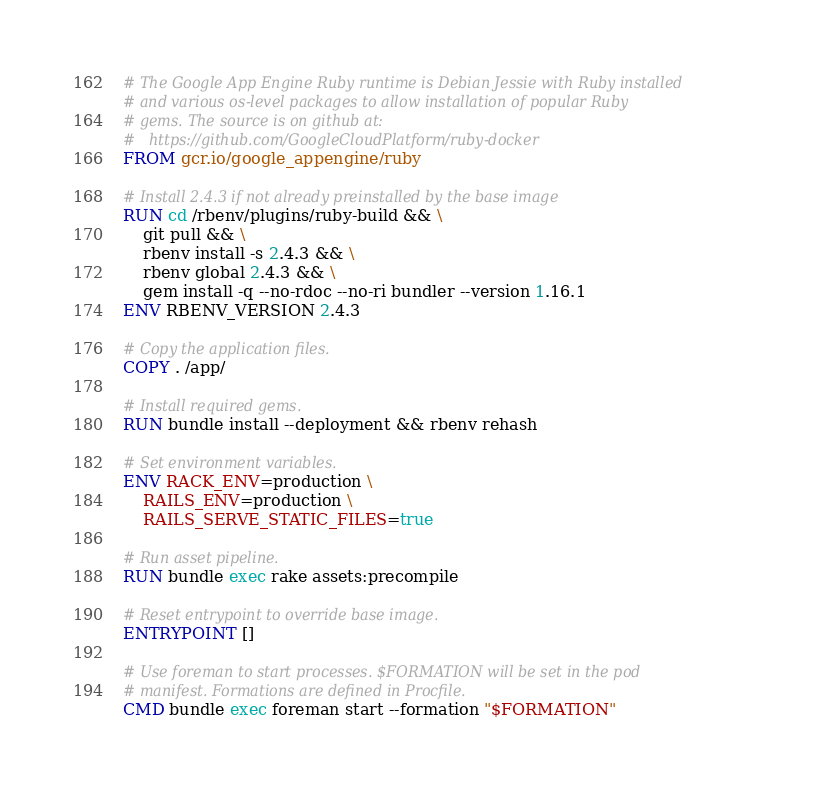<code> <loc_0><loc_0><loc_500><loc_500><_Dockerfile_># The Google App Engine Ruby runtime is Debian Jessie with Ruby installed
# and various os-level packages to allow installation of popular Ruby
# gems. The source is on github at:
#   https://github.com/GoogleCloudPlatform/ruby-docker
FROM gcr.io/google_appengine/ruby

# Install 2.4.3 if not already preinstalled by the base image
RUN cd /rbenv/plugins/ruby-build && \
    git pull && \
    rbenv install -s 2.4.3 && \
    rbenv global 2.4.3 && \
    gem install -q --no-rdoc --no-ri bundler --version 1.16.1
ENV RBENV_VERSION 2.4.3

# Copy the application files.
COPY . /app/

# Install required gems.
RUN bundle install --deployment && rbenv rehash

# Set environment variables.
ENV RACK_ENV=production \
    RAILS_ENV=production \
    RAILS_SERVE_STATIC_FILES=true

# Run asset pipeline.
RUN bundle exec rake assets:precompile

# Reset entrypoint to override base image.
ENTRYPOINT []

# Use foreman to start processes. $FORMATION will be set in the pod
# manifest. Formations are defined in Procfile.
CMD bundle exec foreman start --formation "$FORMATION"
</code> 